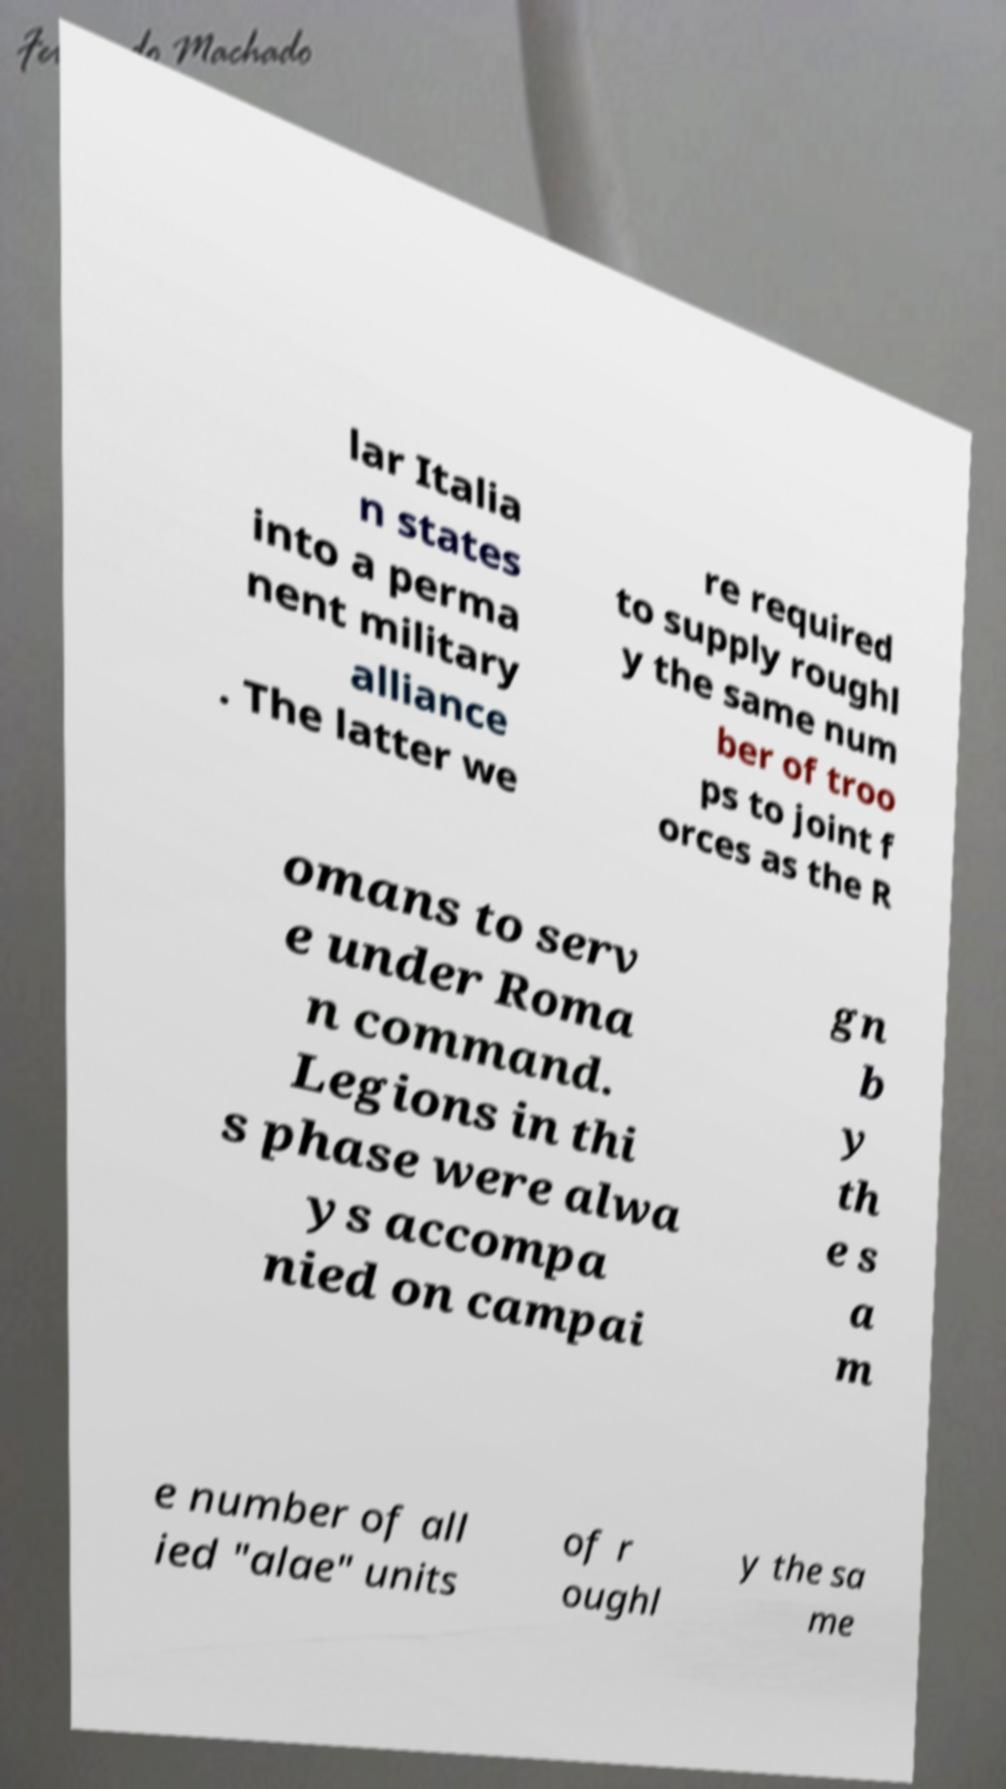Can you accurately transcribe the text from the provided image for me? lar Italia n states into a perma nent military alliance . The latter we re required to supply roughl y the same num ber of troo ps to joint f orces as the R omans to serv e under Roma n command. Legions in thi s phase were alwa ys accompa nied on campai gn b y th e s a m e number of all ied "alae" units of r oughl y the sa me 